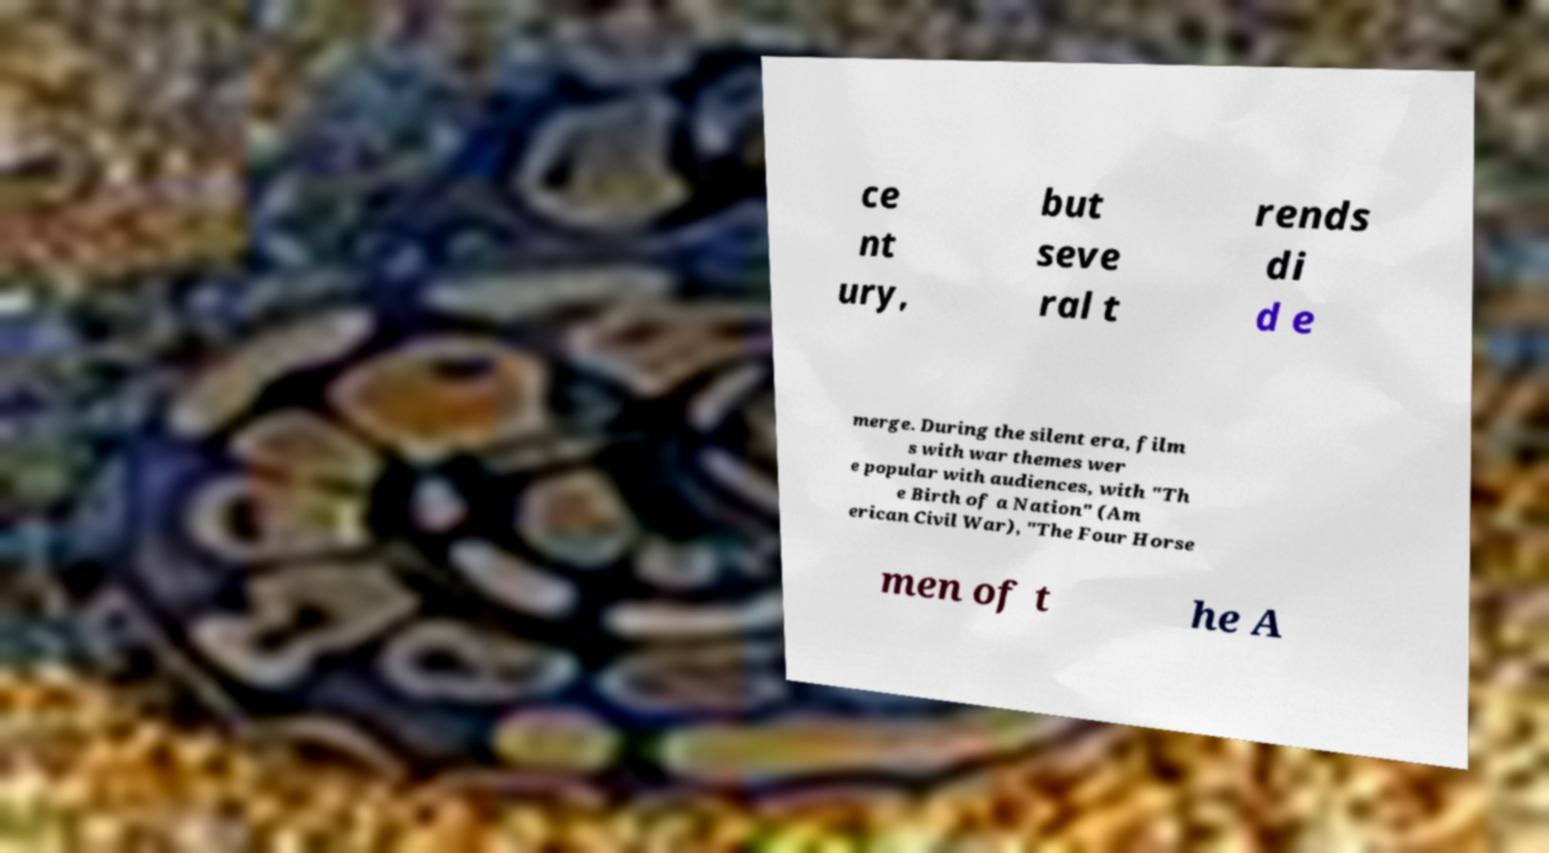Could you assist in decoding the text presented in this image and type it out clearly? ce nt ury, but seve ral t rends di d e merge. During the silent era, film s with war themes wer e popular with audiences, with "Th e Birth of a Nation" (Am erican Civil War), "The Four Horse men of t he A 